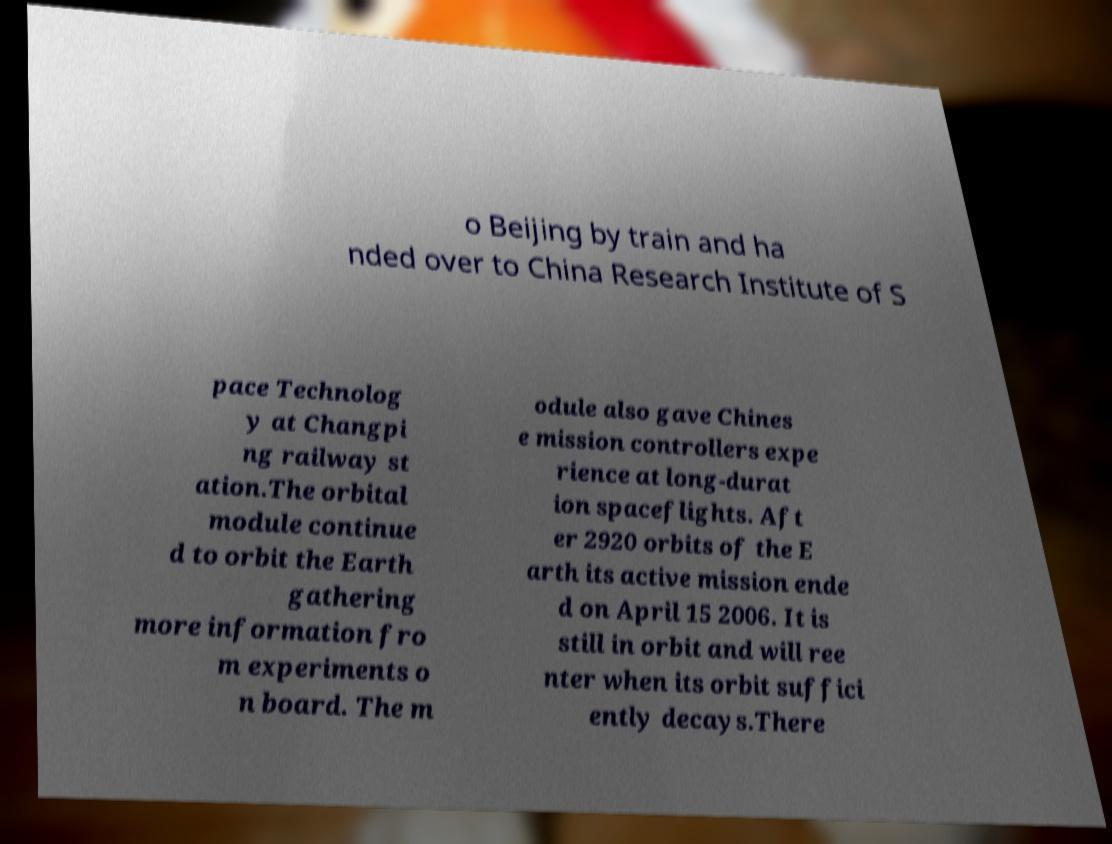I need the written content from this picture converted into text. Can you do that? o Beijing by train and ha nded over to China Research Institute of S pace Technolog y at Changpi ng railway st ation.The orbital module continue d to orbit the Earth gathering more information fro m experiments o n board. The m odule also gave Chines e mission controllers expe rience at long-durat ion spaceflights. Aft er 2920 orbits of the E arth its active mission ende d on April 15 2006. It is still in orbit and will ree nter when its orbit suffici ently decays.There 